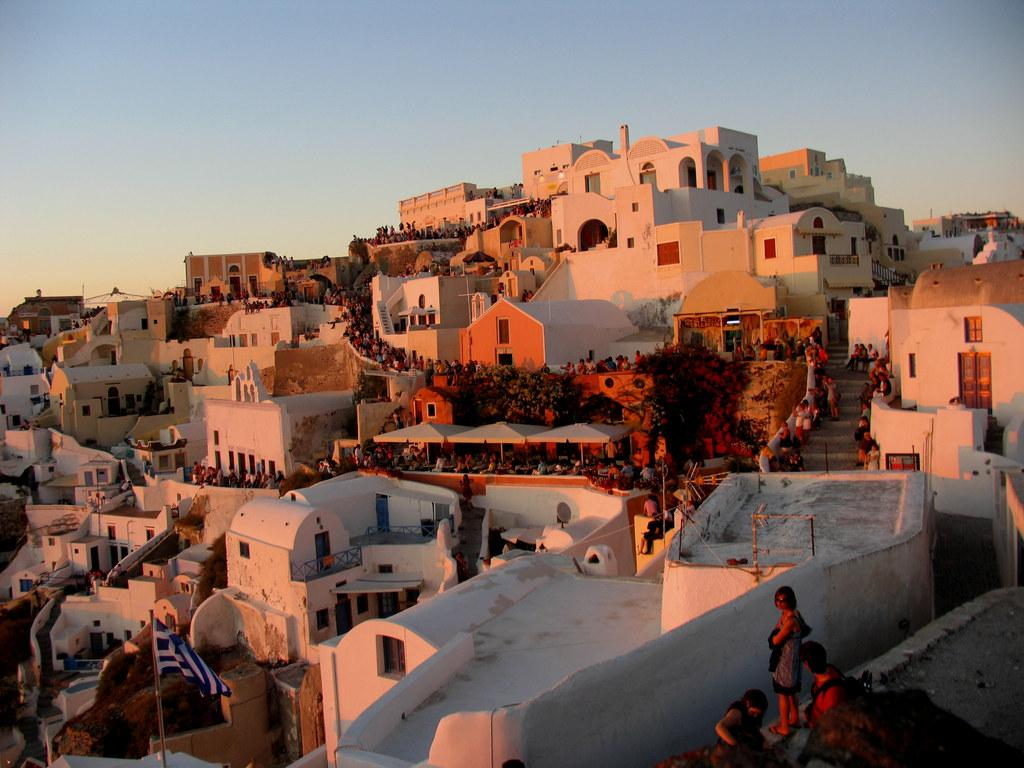What is the main subject of the image? The main subject of the image is many buildings. How close are the buildings to each other? The buildings are close to each other. What are the people in the image doing? The people are standing in a line between the buildings. What is visible at the top of the image? The sky is visible at the top of the image. What color are the people's toes in the image? There is no information about the color of the people's toes in the image, as it focuses on the buildings and people standing in a line. 